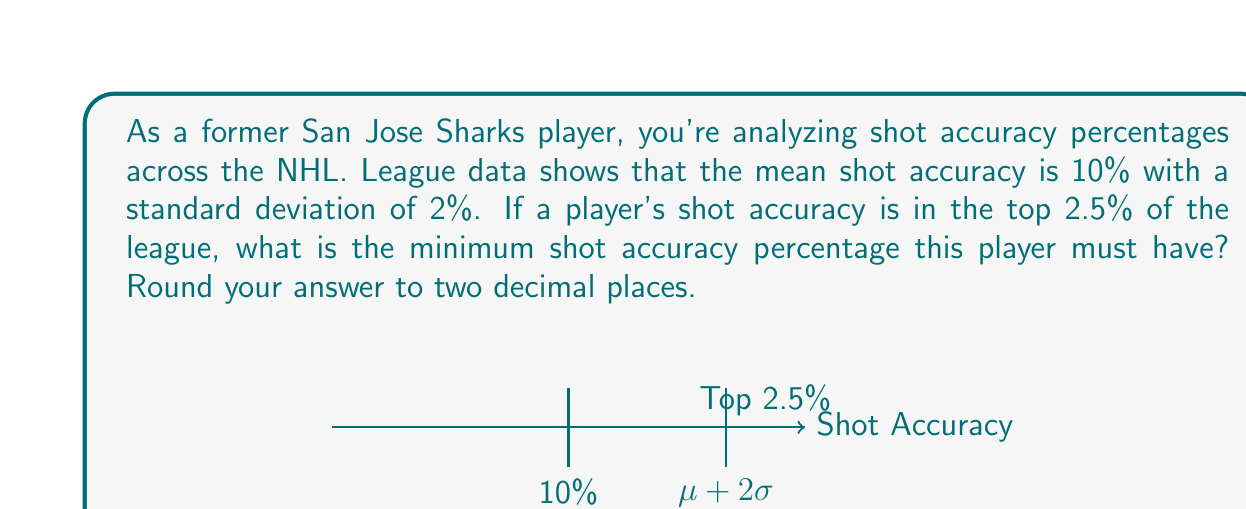Provide a solution to this math problem. Let's approach this step-by-step:

1) We're dealing with a normal distribution where:
   $\mu = 10\%$ (mean)
   $\sigma = 2\%$ (standard deviation)

2) We need to find the z-score that corresponds to the top 2.5% of the distribution. This is equivalent to finding the z-score for the 97.5th percentile (since 100% - 2.5% = 97.5%).

3) From the standard normal distribution table, we know that the z-score for the 97.5th percentile is approximately 1.96.

4) Now, we can use the z-score formula:
   $$z = \frac{x - \mu}{\sigma}$$

   Where:
   $z = 1.96$ (the z-score we found)
   $x$ = the shot accuracy percentage we're looking for
   $\mu = 10\%$ (the mean)
   $\sigma = 2\%$ (the standard deviation)

5) Plugging these values into the formula:
   $$1.96 = \frac{x - 10}{2}$$

6) Solving for $x$:
   $$x = 1.96 * 2 + 10 = 3.92 + 10 = 13.92\%$$

7) Rounding to two decimal places: 13.92%

Therefore, a player must have a shot accuracy of at least 13.92% to be in the top 2.5% of the league.
Answer: 13.92% 